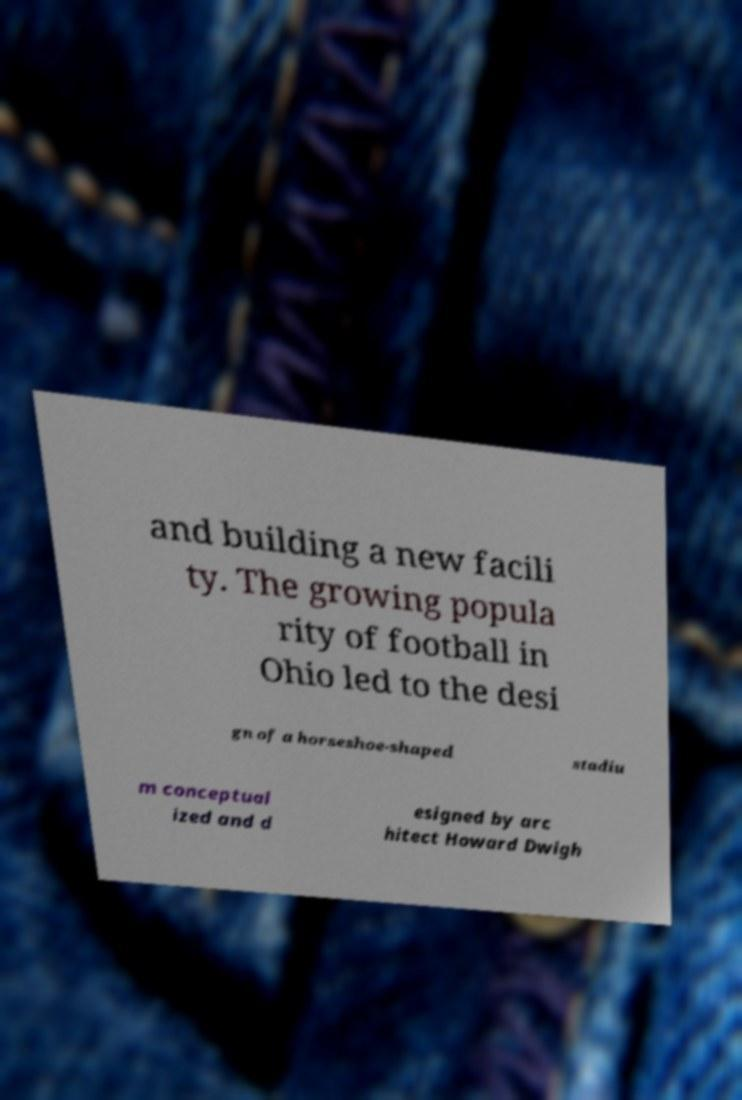Can you accurately transcribe the text from the provided image for me? and building a new facili ty. The growing popula rity of football in Ohio led to the desi gn of a horseshoe-shaped stadiu m conceptual ized and d esigned by arc hitect Howard Dwigh 